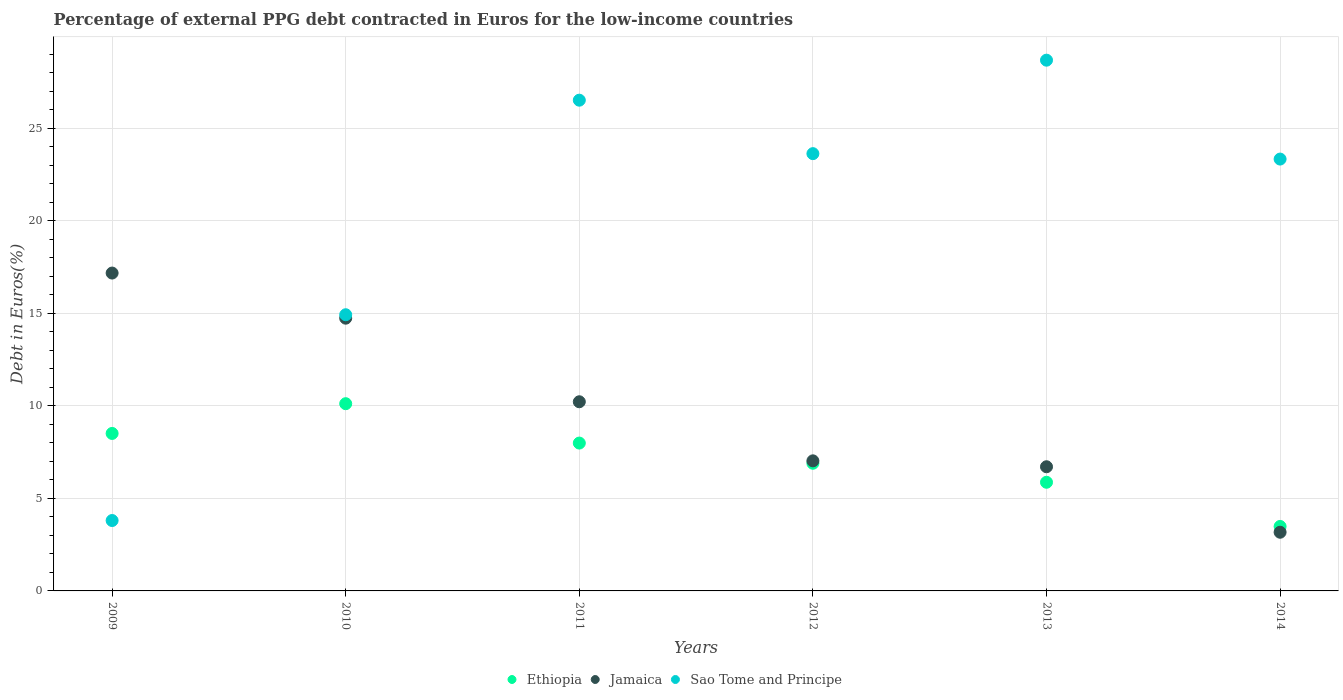How many different coloured dotlines are there?
Provide a succinct answer. 3. Is the number of dotlines equal to the number of legend labels?
Your answer should be compact. Yes. What is the percentage of external PPG debt contracted in Euros in Ethiopia in 2013?
Keep it short and to the point. 5.87. Across all years, what is the maximum percentage of external PPG debt contracted in Euros in Jamaica?
Ensure brevity in your answer.  17.18. Across all years, what is the minimum percentage of external PPG debt contracted in Euros in Ethiopia?
Provide a short and direct response. 3.49. In which year was the percentage of external PPG debt contracted in Euros in Jamaica minimum?
Provide a short and direct response. 2014. What is the total percentage of external PPG debt contracted in Euros in Sao Tome and Principe in the graph?
Your answer should be very brief. 120.94. What is the difference between the percentage of external PPG debt contracted in Euros in Jamaica in 2013 and that in 2014?
Ensure brevity in your answer.  3.54. What is the difference between the percentage of external PPG debt contracted in Euros in Jamaica in 2014 and the percentage of external PPG debt contracted in Euros in Ethiopia in 2009?
Your answer should be very brief. -5.34. What is the average percentage of external PPG debt contracted in Euros in Jamaica per year?
Give a very brief answer. 9.84. In the year 2010, what is the difference between the percentage of external PPG debt contracted in Euros in Sao Tome and Principe and percentage of external PPG debt contracted in Euros in Ethiopia?
Keep it short and to the point. 4.81. In how many years, is the percentage of external PPG debt contracted in Euros in Jamaica greater than 27 %?
Provide a short and direct response. 0. What is the ratio of the percentage of external PPG debt contracted in Euros in Sao Tome and Principe in 2011 to that in 2014?
Offer a terse response. 1.14. What is the difference between the highest and the second highest percentage of external PPG debt contracted in Euros in Sao Tome and Principe?
Offer a very short reply. 2.16. What is the difference between the highest and the lowest percentage of external PPG debt contracted in Euros in Jamaica?
Your answer should be compact. 14.01. Is the sum of the percentage of external PPG debt contracted in Euros in Ethiopia in 2009 and 2011 greater than the maximum percentage of external PPG debt contracted in Euros in Sao Tome and Principe across all years?
Your answer should be compact. No. Does the percentage of external PPG debt contracted in Euros in Jamaica monotonically increase over the years?
Keep it short and to the point. No. Is the percentage of external PPG debt contracted in Euros in Jamaica strictly greater than the percentage of external PPG debt contracted in Euros in Ethiopia over the years?
Make the answer very short. No. How many dotlines are there?
Offer a terse response. 3. How many years are there in the graph?
Provide a succinct answer. 6. What is the difference between two consecutive major ticks on the Y-axis?
Make the answer very short. 5. Are the values on the major ticks of Y-axis written in scientific E-notation?
Your answer should be very brief. No. How are the legend labels stacked?
Keep it short and to the point. Horizontal. What is the title of the graph?
Your answer should be compact. Percentage of external PPG debt contracted in Euros for the low-income countries. What is the label or title of the X-axis?
Keep it short and to the point. Years. What is the label or title of the Y-axis?
Offer a very short reply. Debt in Euros(%). What is the Debt in Euros(%) in Ethiopia in 2009?
Offer a terse response. 8.51. What is the Debt in Euros(%) of Jamaica in 2009?
Give a very brief answer. 17.18. What is the Debt in Euros(%) in Sao Tome and Principe in 2009?
Offer a terse response. 3.81. What is the Debt in Euros(%) in Ethiopia in 2010?
Give a very brief answer. 10.12. What is the Debt in Euros(%) of Jamaica in 2010?
Provide a short and direct response. 14.74. What is the Debt in Euros(%) of Sao Tome and Principe in 2010?
Your response must be concise. 14.93. What is the Debt in Euros(%) in Ethiopia in 2011?
Make the answer very short. 7.99. What is the Debt in Euros(%) in Jamaica in 2011?
Make the answer very short. 10.23. What is the Debt in Euros(%) of Sao Tome and Principe in 2011?
Give a very brief answer. 26.53. What is the Debt in Euros(%) in Ethiopia in 2012?
Offer a very short reply. 6.9. What is the Debt in Euros(%) in Jamaica in 2012?
Offer a very short reply. 7.03. What is the Debt in Euros(%) in Sao Tome and Principe in 2012?
Your answer should be very brief. 23.64. What is the Debt in Euros(%) of Ethiopia in 2013?
Your answer should be very brief. 5.87. What is the Debt in Euros(%) in Jamaica in 2013?
Make the answer very short. 6.71. What is the Debt in Euros(%) in Sao Tome and Principe in 2013?
Your response must be concise. 28.69. What is the Debt in Euros(%) of Ethiopia in 2014?
Your answer should be very brief. 3.49. What is the Debt in Euros(%) in Jamaica in 2014?
Provide a short and direct response. 3.17. What is the Debt in Euros(%) of Sao Tome and Principe in 2014?
Offer a terse response. 23.34. Across all years, what is the maximum Debt in Euros(%) of Ethiopia?
Provide a short and direct response. 10.12. Across all years, what is the maximum Debt in Euros(%) in Jamaica?
Offer a very short reply. 17.18. Across all years, what is the maximum Debt in Euros(%) of Sao Tome and Principe?
Your response must be concise. 28.69. Across all years, what is the minimum Debt in Euros(%) of Ethiopia?
Provide a short and direct response. 3.49. Across all years, what is the minimum Debt in Euros(%) in Jamaica?
Offer a terse response. 3.17. Across all years, what is the minimum Debt in Euros(%) of Sao Tome and Principe?
Give a very brief answer. 3.81. What is the total Debt in Euros(%) of Ethiopia in the graph?
Keep it short and to the point. 42.89. What is the total Debt in Euros(%) in Jamaica in the graph?
Make the answer very short. 59.07. What is the total Debt in Euros(%) of Sao Tome and Principe in the graph?
Keep it short and to the point. 120.94. What is the difference between the Debt in Euros(%) of Ethiopia in 2009 and that in 2010?
Provide a short and direct response. -1.61. What is the difference between the Debt in Euros(%) of Jamaica in 2009 and that in 2010?
Your response must be concise. 2.44. What is the difference between the Debt in Euros(%) in Sao Tome and Principe in 2009 and that in 2010?
Offer a terse response. -11.12. What is the difference between the Debt in Euros(%) of Ethiopia in 2009 and that in 2011?
Ensure brevity in your answer.  0.52. What is the difference between the Debt in Euros(%) in Jamaica in 2009 and that in 2011?
Offer a very short reply. 6.96. What is the difference between the Debt in Euros(%) in Sao Tome and Principe in 2009 and that in 2011?
Offer a terse response. -22.72. What is the difference between the Debt in Euros(%) of Ethiopia in 2009 and that in 2012?
Your answer should be compact. 1.61. What is the difference between the Debt in Euros(%) of Jamaica in 2009 and that in 2012?
Provide a short and direct response. 10.15. What is the difference between the Debt in Euros(%) of Sao Tome and Principe in 2009 and that in 2012?
Provide a succinct answer. -19.83. What is the difference between the Debt in Euros(%) of Ethiopia in 2009 and that in 2013?
Make the answer very short. 2.64. What is the difference between the Debt in Euros(%) of Jamaica in 2009 and that in 2013?
Offer a very short reply. 10.47. What is the difference between the Debt in Euros(%) of Sao Tome and Principe in 2009 and that in 2013?
Keep it short and to the point. -24.89. What is the difference between the Debt in Euros(%) in Ethiopia in 2009 and that in 2014?
Ensure brevity in your answer.  5.03. What is the difference between the Debt in Euros(%) in Jamaica in 2009 and that in 2014?
Provide a succinct answer. 14.01. What is the difference between the Debt in Euros(%) in Sao Tome and Principe in 2009 and that in 2014?
Give a very brief answer. -19.54. What is the difference between the Debt in Euros(%) of Ethiopia in 2010 and that in 2011?
Provide a succinct answer. 2.13. What is the difference between the Debt in Euros(%) in Jamaica in 2010 and that in 2011?
Your response must be concise. 4.52. What is the difference between the Debt in Euros(%) in Sao Tome and Principe in 2010 and that in 2011?
Provide a succinct answer. -11.6. What is the difference between the Debt in Euros(%) of Ethiopia in 2010 and that in 2012?
Offer a terse response. 3.22. What is the difference between the Debt in Euros(%) of Jamaica in 2010 and that in 2012?
Offer a very short reply. 7.71. What is the difference between the Debt in Euros(%) of Sao Tome and Principe in 2010 and that in 2012?
Offer a terse response. -8.71. What is the difference between the Debt in Euros(%) of Ethiopia in 2010 and that in 2013?
Offer a very short reply. 4.25. What is the difference between the Debt in Euros(%) in Jamaica in 2010 and that in 2013?
Your answer should be very brief. 8.03. What is the difference between the Debt in Euros(%) of Sao Tome and Principe in 2010 and that in 2013?
Keep it short and to the point. -13.76. What is the difference between the Debt in Euros(%) in Ethiopia in 2010 and that in 2014?
Give a very brief answer. 6.64. What is the difference between the Debt in Euros(%) in Jamaica in 2010 and that in 2014?
Offer a terse response. 11.57. What is the difference between the Debt in Euros(%) in Sao Tome and Principe in 2010 and that in 2014?
Offer a very short reply. -8.41. What is the difference between the Debt in Euros(%) in Ethiopia in 2011 and that in 2012?
Offer a very short reply. 1.09. What is the difference between the Debt in Euros(%) in Jamaica in 2011 and that in 2012?
Keep it short and to the point. 3.19. What is the difference between the Debt in Euros(%) in Sao Tome and Principe in 2011 and that in 2012?
Make the answer very short. 2.89. What is the difference between the Debt in Euros(%) of Ethiopia in 2011 and that in 2013?
Offer a terse response. 2.12. What is the difference between the Debt in Euros(%) of Jamaica in 2011 and that in 2013?
Offer a very short reply. 3.51. What is the difference between the Debt in Euros(%) in Sao Tome and Principe in 2011 and that in 2013?
Provide a succinct answer. -2.16. What is the difference between the Debt in Euros(%) in Ethiopia in 2011 and that in 2014?
Provide a short and direct response. 4.51. What is the difference between the Debt in Euros(%) in Jamaica in 2011 and that in 2014?
Your answer should be very brief. 7.05. What is the difference between the Debt in Euros(%) of Sao Tome and Principe in 2011 and that in 2014?
Give a very brief answer. 3.18. What is the difference between the Debt in Euros(%) in Ethiopia in 2012 and that in 2013?
Keep it short and to the point. 1.03. What is the difference between the Debt in Euros(%) of Jamaica in 2012 and that in 2013?
Provide a succinct answer. 0.32. What is the difference between the Debt in Euros(%) of Sao Tome and Principe in 2012 and that in 2013?
Make the answer very short. -5.05. What is the difference between the Debt in Euros(%) of Ethiopia in 2012 and that in 2014?
Provide a short and direct response. 3.42. What is the difference between the Debt in Euros(%) in Jamaica in 2012 and that in 2014?
Ensure brevity in your answer.  3.86. What is the difference between the Debt in Euros(%) in Sao Tome and Principe in 2012 and that in 2014?
Offer a very short reply. 0.29. What is the difference between the Debt in Euros(%) in Ethiopia in 2013 and that in 2014?
Offer a very short reply. 2.39. What is the difference between the Debt in Euros(%) in Jamaica in 2013 and that in 2014?
Your answer should be compact. 3.54. What is the difference between the Debt in Euros(%) in Sao Tome and Principe in 2013 and that in 2014?
Give a very brief answer. 5.35. What is the difference between the Debt in Euros(%) in Ethiopia in 2009 and the Debt in Euros(%) in Jamaica in 2010?
Your response must be concise. -6.23. What is the difference between the Debt in Euros(%) of Ethiopia in 2009 and the Debt in Euros(%) of Sao Tome and Principe in 2010?
Offer a very short reply. -6.42. What is the difference between the Debt in Euros(%) of Jamaica in 2009 and the Debt in Euros(%) of Sao Tome and Principe in 2010?
Your response must be concise. 2.25. What is the difference between the Debt in Euros(%) in Ethiopia in 2009 and the Debt in Euros(%) in Jamaica in 2011?
Your response must be concise. -1.71. What is the difference between the Debt in Euros(%) of Ethiopia in 2009 and the Debt in Euros(%) of Sao Tome and Principe in 2011?
Keep it short and to the point. -18.02. What is the difference between the Debt in Euros(%) in Jamaica in 2009 and the Debt in Euros(%) in Sao Tome and Principe in 2011?
Ensure brevity in your answer.  -9.35. What is the difference between the Debt in Euros(%) in Ethiopia in 2009 and the Debt in Euros(%) in Jamaica in 2012?
Provide a short and direct response. 1.48. What is the difference between the Debt in Euros(%) in Ethiopia in 2009 and the Debt in Euros(%) in Sao Tome and Principe in 2012?
Your answer should be very brief. -15.13. What is the difference between the Debt in Euros(%) of Jamaica in 2009 and the Debt in Euros(%) of Sao Tome and Principe in 2012?
Keep it short and to the point. -6.46. What is the difference between the Debt in Euros(%) of Ethiopia in 2009 and the Debt in Euros(%) of Jamaica in 2013?
Offer a very short reply. 1.8. What is the difference between the Debt in Euros(%) of Ethiopia in 2009 and the Debt in Euros(%) of Sao Tome and Principe in 2013?
Give a very brief answer. -20.18. What is the difference between the Debt in Euros(%) of Jamaica in 2009 and the Debt in Euros(%) of Sao Tome and Principe in 2013?
Keep it short and to the point. -11.51. What is the difference between the Debt in Euros(%) of Ethiopia in 2009 and the Debt in Euros(%) of Jamaica in 2014?
Offer a terse response. 5.34. What is the difference between the Debt in Euros(%) in Ethiopia in 2009 and the Debt in Euros(%) in Sao Tome and Principe in 2014?
Your answer should be compact. -14.83. What is the difference between the Debt in Euros(%) of Jamaica in 2009 and the Debt in Euros(%) of Sao Tome and Principe in 2014?
Offer a terse response. -6.16. What is the difference between the Debt in Euros(%) of Ethiopia in 2010 and the Debt in Euros(%) of Jamaica in 2011?
Provide a succinct answer. -0.1. What is the difference between the Debt in Euros(%) of Ethiopia in 2010 and the Debt in Euros(%) of Sao Tome and Principe in 2011?
Your answer should be very brief. -16.41. What is the difference between the Debt in Euros(%) in Jamaica in 2010 and the Debt in Euros(%) in Sao Tome and Principe in 2011?
Ensure brevity in your answer.  -11.78. What is the difference between the Debt in Euros(%) of Ethiopia in 2010 and the Debt in Euros(%) of Jamaica in 2012?
Offer a very short reply. 3.09. What is the difference between the Debt in Euros(%) of Ethiopia in 2010 and the Debt in Euros(%) of Sao Tome and Principe in 2012?
Ensure brevity in your answer.  -13.52. What is the difference between the Debt in Euros(%) of Jamaica in 2010 and the Debt in Euros(%) of Sao Tome and Principe in 2012?
Your answer should be very brief. -8.89. What is the difference between the Debt in Euros(%) of Ethiopia in 2010 and the Debt in Euros(%) of Jamaica in 2013?
Your answer should be compact. 3.41. What is the difference between the Debt in Euros(%) of Ethiopia in 2010 and the Debt in Euros(%) of Sao Tome and Principe in 2013?
Offer a terse response. -18.57. What is the difference between the Debt in Euros(%) of Jamaica in 2010 and the Debt in Euros(%) of Sao Tome and Principe in 2013?
Offer a terse response. -13.95. What is the difference between the Debt in Euros(%) of Ethiopia in 2010 and the Debt in Euros(%) of Jamaica in 2014?
Your response must be concise. 6.95. What is the difference between the Debt in Euros(%) in Ethiopia in 2010 and the Debt in Euros(%) in Sao Tome and Principe in 2014?
Offer a terse response. -13.22. What is the difference between the Debt in Euros(%) in Jamaica in 2010 and the Debt in Euros(%) in Sao Tome and Principe in 2014?
Make the answer very short. -8.6. What is the difference between the Debt in Euros(%) of Ethiopia in 2011 and the Debt in Euros(%) of Jamaica in 2012?
Keep it short and to the point. 0.96. What is the difference between the Debt in Euros(%) of Ethiopia in 2011 and the Debt in Euros(%) of Sao Tome and Principe in 2012?
Your response must be concise. -15.65. What is the difference between the Debt in Euros(%) of Jamaica in 2011 and the Debt in Euros(%) of Sao Tome and Principe in 2012?
Offer a very short reply. -13.41. What is the difference between the Debt in Euros(%) in Ethiopia in 2011 and the Debt in Euros(%) in Jamaica in 2013?
Provide a short and direct response. 1.28. What is the difference between the Debt in Euros(%) of Ethiopia in 2011 and the Debt in Euros(%) of Sao Tome and Principe in 2013?
Your response must be concise. -20.7. What is the difference between the Debt in Euros(%) of Jamaica in 2011 and the Debt in Euros(%) of Sao Tome and Principe in 2013?
Provide a short and direct response. -18.47. What is the difference between the Debt in Euros(%) in Ethiopia in 2011 and the Debt in Euros(%) in Jamaica in 2014?
Your answer should be very brief. 4.82. What is the difference between the Debt in Euros(%) in Ethiopia in 2011 and the Debt in Euros(%) in Sao Tome and Principe in 2014?
Provide a short and direct response. -15.35. What is the difference between the Debt in Euros(%) of Jamaica in 2011 and the Debt in Euros(%) of Sao Tome and Principe in 2014?
Offer a terse response. -13.12. What is the difference between the Debt in Euros(%) of Ethiopia in 2012 and the Debt in Euros(%) of Jamaica in 2013?
Keep it short and to the point. 0.19. What is the difference between the Debt in Euros(%) in Ethiopia in 2012 and the Debt in Euros(%) in Sao Tome and Principe in 2013?
Provide a short and direct response. -21.79. What is the difference between the Debt in Euros(%) of Jamaica in 2012 and the Debt in Euros(%) of Sao Tome and Principe in 2013?
Offer a very short reply. -21.66. What is the difference between the Debt in Euros(%) of Ethiopia in 2012 and the Debt in Euros(%) of Jamaica in 2014?
Offer a terse response. 3.73. What is the difference between the Debt in Euros(%) in Ethiopia in 2012 and the Debt in Euros(%) in Sao Tome and Principe in 2014?
Provide a short and direct response. -16.44. What is the difference between the Debt in Euros(%) in Jamaica in 2012 and the Debt in Euros(%) in Sao Tome and Principe in 2014?
Offer a terse response. -16.31. What is the difference between the Debt in Euros(%) of Ethiopia in 2013 and the Debt in Euros(%) of Jamaica in 2014?
Provide a succinct answer. 2.7. What is the difference between the Debt in Euros(%) of Ethiopia in 2013 and the Debt in Euros(%) of Sao Tome and Principe in 2014?
Your answer should be very brief. -17.47. What is the difference between the Debt in Euros(%) of Jamaica in 2013 and the Debt in Euros(%) of Sao Tome and Principe in 2014?
Offer a terse response. -16.63. What is the average Debt in Euros(%) of Ethiopia per year?
Give a very brief answer. 7.15. What is the average Debt in Euros(%) of Jamaica per year?
Your response must be concise. 9.84. What is the average Debt in Euros(%) in Sao Tome and Principe per year?
Offer a very short reply. 20.16. In the year 2009, what is the difference between the Debt in Euros(%) in Ethiopia and Debt in Euros(%) in Jamaica?
Keep it short and to the point. -8.67. In the year 2009, what is the difference between the Debt in Euros(%) in Ethiopia and Debt in Euros(%) in Sao Tome and Principe?
Ensure brevity in your answer.  4.71. In the year 2009, what is the difference between the Debt in Euros(%) in Jamaica and Debt in Euros(%) in Sao Tome and Principe?
Your response must be concise. 13.38. In the year 2010, what is the difference between the Debt in Euros(%) of Ethiopia and Debt in Euros(%) of Jamaica?
Make the answer very short. -4.62. In the year 2010, what is the difference between the Debt in Euros(%) of Ethiopia and Debt in Euros(%) of Sao Tome and Principe?
Offer a very short reply. -4.81. In the year 2010, what is the difference between the Debt in Euros(%) in Jamaica and Debt in Euros(%) in Sao Tome and Principe?
Offer a very short reply. -0.19. In the year 2011, what is the difference between the Debt in Euros(%) of Ethiopia and Debt in Euros(%) of Jamaica?
Provide a succinct answer. -2.23. In the year 2011, what is the difference between the Debt in Euros(%) in Ethiopia and Debt in Euros(%) in Sao Tome and Principe?
Your answer should be compact. -18.54. In the year 2011, what is the difference between the Debt in Euros(%) in Jamaica and Debt in Euros(%) in Sao Tome and Principe?
Your response must be concise. -16.3. In the year 2012, what is the difference between the Debt in Euros(%) of Ethiopia and Debt in Euros(%) of Jamaica?
Ensure brevity in your answer.  -0.13. In the year 2012, what is the difference between the Debt in Euros(%) in Ethiopia and Debt in Euros(%) in Sao Tome and Principe?
Ensure brevity in your answer.  -16.74. In the year 2012, what is the difference between the Debt in Euros(%) in Jamaica and Debt in Euros(%) in Sao Tome and Principe?
Keep it short and to the point. -16.61. In the year 2013, what is the difference between the Debt in Euros(%) of Ethiopia and Debt in Euros(%) of Jamaica?
Provide a short and direct response. -0.84. In the year 2013, what is the difference between the Debt in Euros(%) of Ethiopia and Debt in Euros(%) of Sao Tome and Principe?
Your response must be concise. -22.82. In the year 2013, what is the difference between the Debt in Euros(%) in Jamaica and Debt in Euros(%) in Sao Tome and Principe?
Ensure brevity in your answer.  -21.98. In the year 2014, what is the difference between the Debt in Euros(%) in Ethiopia and Debt in Euros(%) in Jamaica?
Provide a short and direct response. 0.31. In the year 2014, what is the difference between the Debt in Euros(%) in Ethiopia and Debt in Euros(%) in Sao Tome and Principe?
Provide a short and direct response. -19.86. In the year 2014, what is the difference between the Debt in Euros(%) of Jamaica and Debt in Euros(%) of Sao Tome and Principe?
Your answer should be very brief. -20.17. What is the ratio of the Debt in Euros(%) in Ethiopia in 2009 to that in 2010?
Your response must be concise. 0.84. What is the ratio of the Debt in Euros(%) in Jamaica in 2009 to that in 2010?
Provide a short and direct response. 1.17. What is the ratio of the Debt in Euros(%) in Sao Tome and Principe in 2009 to that in 2010?
Make the answer very short. 0.25. What is the ratio of the Debt in Euros(%) in Ethiopia in 2009 to that in 2011?
Offer a very short reply. 1.07. What is the ratio of the Debt in Euros(%) of Jamaica in 2009 to that in 2011?
Provide a short and direct response. 1.68. What is the ratio of the Debt in Euros(%) of Sao Tome and Principe in 2009 to that in 2011?
Provide a succinct answer. 0.14. What is the ratio of the Debt in Euros(%) of Ethiopia in 2009 to that in 2012?
Provide a short and direct response. 1.23. What is the ratio of the Debt in Euros(%) in Jamaica in 2009 to that in 2012?
Keep it short and to the point. 2.44. What is the ratio of the Debt in Euros(%) in Sao Tome and Principe in 2009 to that in 2012?
Offer a terse response. 0.16. What is the ratio of the Debt in Euros(%) in Ethiopia in 2009 to that in 2013?
Provide a succinct answer. 1.45. What is the ratio of the Debt in Euros(%) of Jamaica in 2009 to that in 2013?
Make the answer very short. 2.56. What is the ratio of the Debt in Euros(%) of Sao Tome and Principe in 2009 to that in 2013?
Your answer should be compact. 0.13. What is the ratio of the Debt in Euros(%) in Ethiopia in 2009 to that in 2014?
Provide a short and direct response. 2.44. What is the ratio of the Debt in Euros(%) in Jamaica in 2009 to that in 2014?
Give a very brief answer. 5.42. What is the ratio of the Debt in Euros(%) of Sao Tome and Principe in 2009 to that in 2014?
Offer a terse response. 0.16. What is the ratio of the Debt in Euros(%) of Ethiopia in 2010 to that in 2011?
Offer a very short reply. 1.27. What is the ratio of the Debt in Euros(%) of Jamaica in 2010 to that in 2011?
Your response must be concise. 1.44. What is the ratio of the Debt in Euros(%) in Sao Tome and Principe in 2010 to that in 2011?
Your response must be concise. 0.56. What is the ratio of the Debt in Euros(%) in Ethiopia in 2010 to that in 2012?
Give a very brief answer. 1.47. What is the ratio of the Debt in Euros(%) in Jamaica in 2010 to that in 2012?
Your response must be concise. 2.1. What is the ratio of the Debt in Euros(%) of Sao Tome and Principe in 2010 to that in 2012?
Your answer should be very brief. 0.63. What is the ratio of the Debt in Euros(%) in Ethiopia in 2010 to that in 2013?
Your response must be concise. 1.72. What is the ratio of the Debt in Euros(%) in Jamaica in 2010 to that in 2013?
Make the answer very short. 2.2. What is the ratio of the Debt in Euros(%) in Sao Tome and Principe in 2010 to that in 2013?
Your answer should be very brief. 0.52. What is the ratio of the Debt in Euros(%) of Ethiopia in 2010 to that in 2014?
Provide a succinct answer. 2.9. What is the ratio of the Debt in Euros(%) of Jamaica in 2010 to that in 2014?
Provide a short and direct response. 4.65. What is the ratio of the Debt in Euros(%) of Sao Tome and Principe in 2010 to that in 2014?
Ensure brevity in your answer.  0.64. What is the ratio of the Debt in Euros(%) in Ethiopia in 2011 to that in 2012?
Your response must be concise. 1.16. What is the ratio of the Debt in Euros(%) in Jamaica in 2011 to that in 2012?
Your answer should be compact. 1.45. What is the ratio of the Debt in Euros(%) in Sao Tome and Principe in 2011 to that in 2012?
Your answer should be compact. 1.12. What is the ratio of the Debt in Euros(%) of Ethiopia in 2011 to that in 2013?
Ensure brevity in your answer.  1.36. What is the ratio of the Debt in Euros(%) in Jamaica in 2011 to that in 2013?
Give a very brief answer. 1.52. What is the ratio of the Debt in Euros(%) in Sao Tome and Principe in 2011 to that in 2013?
Your response must be concise. 0.92. What is the ratio of the Debt in Euros(%) in Ethiopia in 2011 to that in 2014?
Provide a succinct answer. 2.29. What is the ratio of the Debt in Euros(%) in Jamaica in 2011 to that in 2014?
Give a very brief answer. 3.22. What is the ratio of the Debt in Euros(%) of Sao Tome and Principe in 2011 to that in 2014?
Offer a very short reply. 1.14. What is the ratio of the Debt in Euros(%) of Ethiopia in 2012 to that in 2013?
Your answer should be compact. 1.17. What is the ratio of the Debt in Euros(%) of Jamaica in 2012 to that in 2013?
Make the answer very short. 1.05. What is the ratio of the Debt in Euros(%) of Sao Tome and Principe in 2012 to that in 2013?
Your answer should be compact. 0.82. What is the ratio of the Debt in Euros(%) in Ethiopia in 2012 to that in 2014?
Your answer should be very brief. 1.98. What is the ratio of the Debt in Euros(%) in Jamaica in 2012 to that in 2014?
Your answer should be very brief. 2.22. What is the ratio of the Debt in Euros(%) in Sao Tome and Principe in 2012 to that in 2014?
Provide a short and direct response. 1.01. What is the ratio of the Debt in Euros(%) of Ethiopia in 2013 to that in 2014?
Make the answer very short. 1.69. What is the ratio of the Debt in Euros(%) in Jamaica in 2013 to that in 2014?
Your response must be concise. 2.12. What is the ratio of the Debt in Euros(%) in Sao Tome and Principe in 2013 to that in 2014?
Make the answer very short. 1.23. What is the difference between the highest and the second highest Debt in Euros(%) in Ethiopia?
Your answer should be compact. 1.61. What is the difference between the highest and the second highest Debt in Euros(%) of Jamaica?
Provide a succinct answer. 2.44. What is the difference between the highest and the second highest Debt in Euros(%) of Sao Tome and Principe?
Your answer should be compact. 2.16. What is the difference between the highest and the lowest Debt in Euros(%) of Ethiopia?
Keep it short and to the point. 6.64. What is the difference between the highest and the lowest Debt in Euros(%) of Jamaica?
Make the answer very short. 14.01. What is the difference between the highest and the lowest Debt in Euros(%) of Sao Tome and Principe?
Your answer should be very brief. 24.89. 